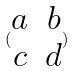Convert formula to latex. <formula><loc_0><loc_0><loc_500><loc_500>( \begin{matrix} a & b \\ c & d \end{matrix} )</formula> 